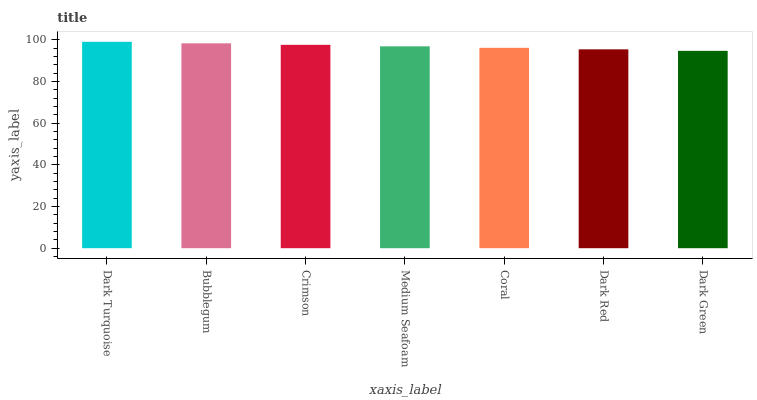Is Dark Green the minimum?
Answer yes or no. Yes. Is Dark Turquoise the maximum?
Answer yes or no. Yes. Is Bubblegum the minimum?
Answer yes or no. No. Is Bubblegum the maximum?
Answer yes or no. No. Is Dark Turquoise greater than Bubblegum?
Answer yes or no. Yes. Is Bubblegum less than Dark Turquoise?
Answer yes or no. Yes. Is Bubblegum greater than Dark Turquoise?
Answer yes or no. No. Is Dark Turquoise less than Bubblegum?
Answer yes or no. No. Is Medium Seafoam the high median?
Answer yes or no. Yes. Is Medium Seafoam the low median?
Answer yes or no. Yes. Is Dark Turquoise the high median?
Answer yes or no. No. Is Crimson the low median?
Answer yes or no. No. 